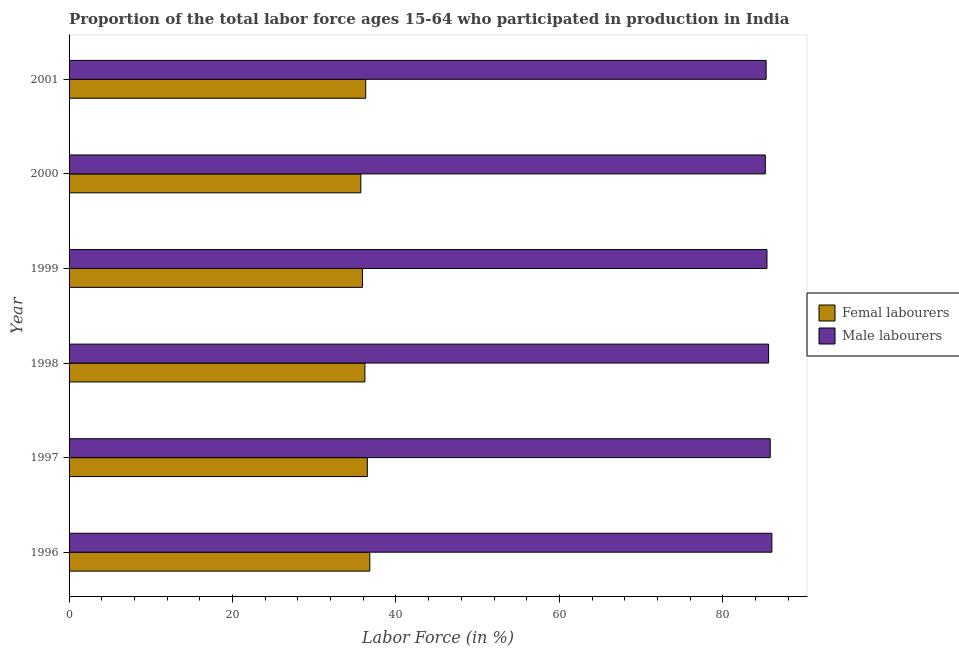How many groups of bars are there?
Your answer should be compact. 6. Are the number of bars on each tick of the Y-axis equal?
Your answer should be very brief. Yes. What is the percentage of male labour force in 1999?
Provide a short and direct response. 85.4. Across all years, what is the maximum percentage of female labor force?
Keep it short and to the point. 36.8. Across all years, what is the minimum percentage of male labour force?
Make the answer very short. 85.2. In which year was the percentage of male labour force maximum?
Offer a terse response. 1996. What is the total percentage of female labor force in the graph?
Offer a very short reply. 217.4. What is the difference between the percentage of male labour force in 1997 and that in 2001?
Ensure brevity in your answer.  0.5. What is the difference between the percentage of male labour force in 1999 and the percentage of female labor force in 2001?
Give a very brief answer. 49.1. What is the average percentage of male labour force per year?
Offer a very short reply. 85.55. In the year 2000, what is the difference between the percentage of male labour force and percentage of female labor force?
Make the answer very short. 49.5. Is the difference between the percentage of female labor force in 1996 and 1999 greater than the difference between the percentage of male labour force in 1996 and 1999?
Keep it short and to the point. Yes. What is the difference between the highest and the second highest percentage of female labor force?
Give a very brief answer. 0.3. In how many years, is the percentage of female labor force greater than the average percentage of female labor force taken over all years?
Keep it short and to the point. 3. What does the 2nd bar from the top in 1996 represents?
Keep it short and to the point. Femal labourers. What does the 2nd bar from the bottom in 2000 represents?
Give a very brief answer. Male labourers. How many bars are there?
Make the answer very short. 12. Are the values on the major ticks of X-axis written in scientific E-notation?
Give a very brief answer. No. Does the graph contain any zero values?
Offer a terse response. No. Where does the legend appear in the graph?
Make the answer very short. Center right. How many legend labels are there?
Offer a terse response. 2. What is the title of the graph?
Offer a terse response. Proportion of the total labor force ages 15-64 who participated in production in India. Does "Merchandise exports" appear as one of the legend labels in the graph?
Your answer should be very brief. No. What is the label or title of the X-axis?
Ensure brevity in your answer.  Labor Force (in %). What is the Labor Force (in %) in Femal labourers in 1996?
Provide a succinct answer. 36.8. What is the Labor Force (in %) of Male labourers in 1996?
Your answer should be compact. 86. What is the Labor Force (in %) in Femal labourers in 1997?
Offer a terse response. 36.5. What is the Labor Force (in %) of Male labourers in 1997?
Give a very brief answer. 85.8. What is the Labor Force (in %) of Femal labourers in 1998?
Offer a terse response. 36.2. What is the Labor Force (in %) in Male labourers in 1998?
Offer a terse response. 85.6. What is the Labor Force (in %) of Femal labourers in 1999?
Your answer should be very brief. 35.9. What is the Labor Force (in %) in Male labourers in 1999?
Your answer should be very brief. 85.4. What is the Labor Force (in %) of Femal labourers in 2000?
Your answer should be compact. 35.7. What is the Labor Force (in %) in Male labourers in 2000?
Ensure brevity in your answer.  85.2. What is the Labor Force (in %) of Femal labourers in 2001?
Ensure brevity in your answer.  36.3. What is the Labor Force (in %) in Male labourers in 2001?
Provide a short and direct response. 85.3. Across all years, what is the maximum Labor Force (in %) in Femal labourers?
Provide a short and direct response. 36.8. Across all years, what is the maximum Labor Force (in %) of Male labourers?
Your answer should be very brief. 86. Across all years, what is the minimum Labor Force (in %) of Femal labourers?
Give a very brief answer. 35.7. Across all years, what is the minimum Labor Force (in %) of Male labourers?
Your response must be concise. 85.2. What is the total Labor Force (in %) of Femal labourers in the graph?
Offer a very short reply. 217.4. What is the total Labor Force (in %) in Male labourers in the graph?
Provide a short and direct response. 513.3. What is the difference between the Labor Force (in %) of Male labourers in 1996 and that in 1997?
Your answer should be compact. 0.2. What is the difference between the Labor Force (in %) in Femal labourers in 1996 and that in 1998?
Provide a short and direct response. 0.6. What is the difference between the Labor Force (in %) of Femal labourers in 1996 and that in 1999?
Your answer should be very brief. 0.9. What is the difference between the Labor Force (in %) of Femal labourers in 1996 and that in 2000?
Give a very brief answer. 1.1. What is the difference between the Labor Force (in %) in Femal labourers in 1996 and that in 2001?
Your response must be concise. 0.5. What is the difference between the Labor Force (in %) of Femal labourers in 1997 and that in 1998?
Offer a very short reply. 0.3. What is the difference between the Labor Force (in %) in Male labourers in 1997 and that in 1998?
Keep it short and to the point. 0.2. What is the difference between the Labor Force (in %) of Femal labourers in 1997 and that in 1999?
Keep it short and to the point. 0.6. What is the difference between the Labor Force (in %) in Male labourers in 1997 and that in 1999?
Keep it short and to the point. 0.4. What is the difference between the Labor Force (in %) of Femal labourers in 1997 and that in 2000?
Give a very brief answer. 0.8. What is the difference between the Labor Force (in %) in Male labourers in 1997 and that in 2000?
Make the answer very short. 0.6. What is the difference between the Labor Force (in %) in Femal labourers in 1997 and that in 2001?
Provide a short and direct response. 0.2. What is the difference between the Labor Force (in %) in Male labourers in 1997 and that in 2001?
Your answer should be very brief. 0.5. What is the difference between the Labor Force (in %) of Male labourers in 1998 and that in 2000?
Your answer should be compact. 0.4. What is the difference between the Labor Force (in %) in Male labourers in 1998 and that in 2001?
Make the answer very short. 0.3. What is the difference between the Labor Force (in %) in Male labourers in 1999 and that in 2000?
Give a very brief answer. 0.2. What is the difference between the Labor Force (in %) of Femal labourers in 1999 and that in 2001?
Ensure brevity in your answer.  -0.4. What is the difference between the Labor Force (in %) in Male labourers in 1999 and that in 2001?
Offer a terse response. 0.1. What is the difference between the Labor Force (in %) of Femal labourers in 1996 and the Labor Force (in %) of Male labourers in 1997?
Offer a terse response. -49. What is the difference between the Labor Force (in %) of Femal labourers in 1996 and the Labor Force (in %) of Male labourers in 1998?
Your response must be concise. -48.8. What is the difference between the Labor Force (in %) of Femal labourers in 1996 and the Labor Force (in %) of Male labourers in 1999?
Offer a terse response. -48.6. What is the difference between the Labor Force (in %) of Femal labourers in 1996 and the Labor Force (in %) of Male labourers in 2000?
Keep it short and to the point. -48.4. What is the difference between the Labor Force (in %) in Femal labourers in 1996 and the Labor Force (in %) in Male labourers in 2001?
Provide a succinct answer. -48.5. What is the difference between the Labor Force (in %) in Femal labourers in 1997 and the Labor Force (in %) in Male labourers in 1998?
Give a very brief answer. -49.1. What is the difference between the Labor Force (in %) of Femal labourers in 1997 and the Labor Force (in %) of Male labourers in 1999?
Your answer should be compact. -48.9. What is the difference between the Labor Force (in %) in Femal labourers in 1997 and the Labor Force (in %) in Male labourers in 2000?
Your answer should be compact. -48.7. What is the difference between the Labor Force (in %) of Femal labourers in 1997 and the Labor Force (in %) of Male labourers in 2001?
Offer a terse response. -48.8. What is the difference between the Labor Force (in %) of Femal labourers in 1998 and the Labor Force (in %) of Male labourers in 1999?
Give a very brief answer. -49.2. What is the difference between the Labor Force (in %) of Femal labourers in 1998 and the Labor Force (in %) of Male labourers in 2000?
Ensure brevity in your answer.  -49. What is the difference between the Labor Force (in %) of Femal labourers in 1998 and the Labor Force (in %) of Male labourers in 2001?
Make the answer very short. -49.1. What is the difference between the Labor Force (in %) in Femal labourers in 1999 and the Labor Force (in %) in Male labourers in 2000?
Your response must be concise. -49.3. What is the difference between the Labor Force (in %) in Femal labourers in 1999 and the Labor Force (in %) in Male labourers in 2001?
Offer a terse response. -49.4. What is the difference between the Labor Force (in %) in Femal labourers in 2000 and the Labor Force (in %) in Male labourers in 2001?
Make the answer very short. -49.6. What is the average Labor Force (in %) in Femal labourers per year?
Keep it short and to the point. 36.23. What is the average Labor Force (in %) in Male labourers per year?
Your answer should be very brief. 85.55. In the year 1996, what is the difference between the Labor Force (in %) of Femal labourers and Labor Force (in %) of Male labourers?
Your answer should be compact. -49.2. In the year 1997, what is the difference between the Labor Force (in %) in Femal labourers and Labor Force (in %) in Male labourers?
Offer a terse response. -49.3. In the year 1998, what is the difference between the Labor Force (in %) of Femal labourers and Labor Force (in %) of Male labourers?
Make the answer very short. -49.4. In the year 1999, what is the difference between the Labor Force (in %) in Femal labourers and Labor Force (in %) in Male labourers?
Provide a succinct answer. -49.5. In the year 2000, what is the difference between the Labor Force (in %) of Femal labourers and Labor Force (in %) of Male labourers?
Your answer should be very brief. -49.5. In the year 2001, what is the difference between the Labor Force (in %) of Femal labourers and Labor Force (in %) of Male labourers?
Provide a short and direct response. -49. What is the ratio of the Labor Force (in %) of Femal labourers in 1996 to that in 1997?
Your answer should be compact. 1.01. What is the ratio of the Labor Force (in %) of Femal labourers in 1996 to that in 1998?
Provide a short and direct response. 1.02. What is the ratio of the Labor Force (in %) of Male labourers in 1996 to that in 1998?
Your answer should be compact. 1. What is the ratio of the Labor Force (in %) in Femal labourers in 1996 to that in 1999?
Offer a terse response. 1.03. What is the ratio of the Labor Force (in %) of Male labourers in 1996 to that in 1999?
Keep it short and to the point. 1.01. What is the ratio of the Labor Force (in %) in Femal labourers in 1996 to that in 2000?
Ensure brevity in your answer.  1.03. What is the ratio of the Labor Force (in %) in Male labourers in 1996 to that in 2000?
Give a very brief answer. 1.01. What is the ratio of the Labor Force (in %) of Femal labourers in 1996 to that in 2001?
Provide a short and direct response. 1.01. What is the ratio of the Labor Force (in %) in Male labourers in 1996 to that in 2001?
Provide a short and direct response. 1.01. What is the ratio of the Labor Force (in %) in Femal labourers in 1997 to that in 1998?
Your answer should be compact. 1.01. What is the ratio of the Labor Force (in %) of Male labourers in 1997 to that in 1998?
Your answer should be compact. 1. What is the ratio of the Labor Force (in %) in Femal labourers in 1997 to that in 1999?
Give a very brief answer. 1.02. What is the ratio of the Labor Force (in %) in Femal labourers in 1997 to that in 2000?
Offer a terse response. 1.02. What is the ratio of the Labor Force (in %) in Male labourers in 1997 to that in 2000?
Your response must be concise. 1.01. What is the ratio of the Labor Force (in %) in Femal labourers in 1997 to that in 2001?
Ensure brevity in your answer.  1.01. What is the ratio of the Labor Force (in %) in Male labourers in 1997 to that in 2001?
Give a very brief answer. 1.01. What is the ratio of the Labor Force (in %) in Femal labourers in 1998 to that in 1999?
Give a very brief answer. 1.01. What is the ratio of the Labor Force (in %) in Male labourers in 1998 to that in 1999?
Keep it short and to the point. 1. What is the ratio of the Labor Force (in %) in Femal labourers in 1998 to that in 2000?
Keep it short and to the point. 1.01. What is the ratio of the Labor Force (in %) of Femal labourers in 1998 to that in 2001?
Ensure brevity in your answer.  1. What is the ratio of the Labor Force (in %) in Femal labourers in 1999 to that in 2000?
Your answer should be compact. 1.01. What is the ratio of the Labor Force (in %) in Femal labourers in 2000 to that in 2001?
Offer a very short reply. 0.98. What is the ratio of the Labor Force (in %) in Male labourers in 2000 to that in 2001?
Your response must be concise. 1. What is the difference between the highest and the second highest Labor Force (in %) in Femal labourers?
Your answer should be compact. 0.3. What is the difference between the highest and the lowest Labor Force (in %) in Femal labourers?
Ensure brevity in your answer.  1.1. 